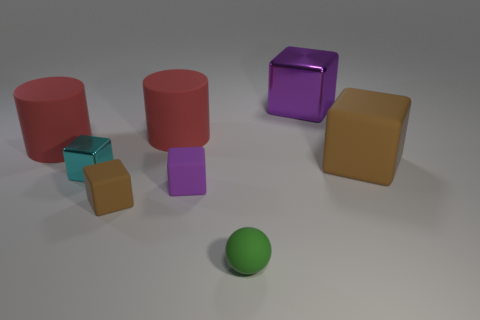There is a cyan block; is its size the same as the purple thing in front of the cyan block?
Your response must be concise. Yes. There is a brown rubber block on the left side of the red matte thing on the right side of the brown block in front of the tiny shiny block; what is its size?
Your answer should be very brief. Small. How many metal cubes are behind the small cyan cube?
Your answer should be very brief. 1. What material is the large cube behind the block that is right of the purple metal thing?
Offer a terse response. Metal. Do the purple rubber cube and the matte sphere have the same size?
Your answer should be very brief. Yes. What number of things are either large blocks that are on the right side of the large purple shiny cube or large matte objects that are on the left side of the rubber sphere?
Keep it short and to the point. 3. Is the number of shiny blocks on the left side of the large metal cube greater than the number of large blue matte cylinders?
Offer a terse response. Yes. How many other things are there of the same shape as the green object?
Give a very brief answer. 0. What is the small thing that is in front of the purple matte block and on the left side of the small purple block made of?
Keep it short and to the point. Rubber. What number of things are red matte cylinders or purple blocks?
Ensure brevity in your answer.  4. 